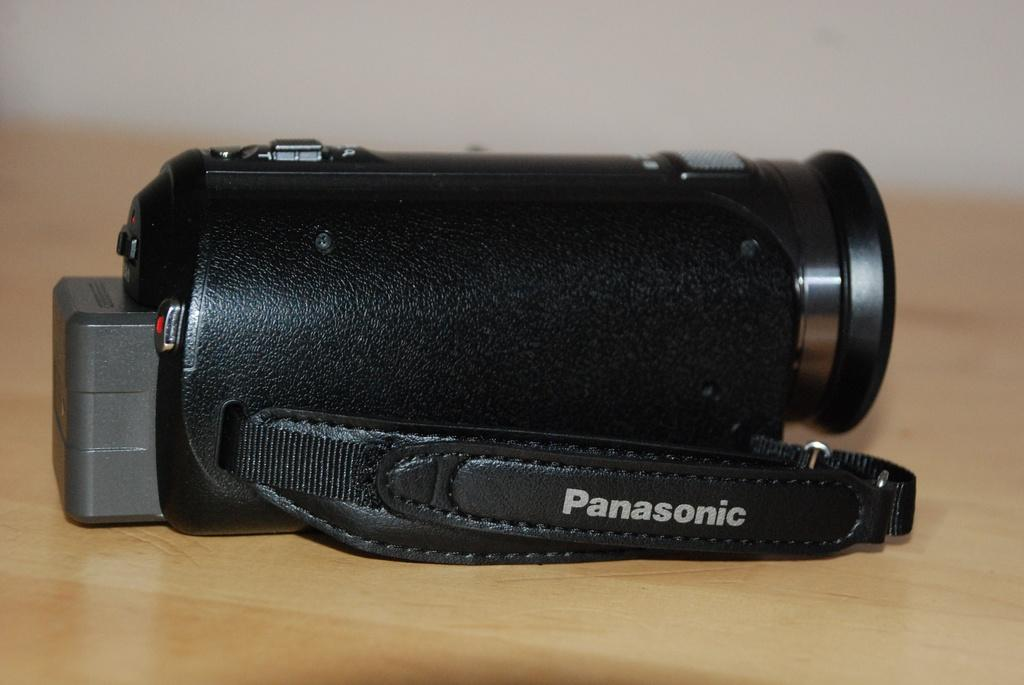What is the main object in the image? There is a camera in the image. Where is the camera placed? The camera is placed on a wooden table. Can you describe the background in the image? The backdrop in the image is blurred. What type of discussion is taking place in the image? There is no discussion taking place in the image; it features a camera placed on a wooden table with a blurred backdrop. 